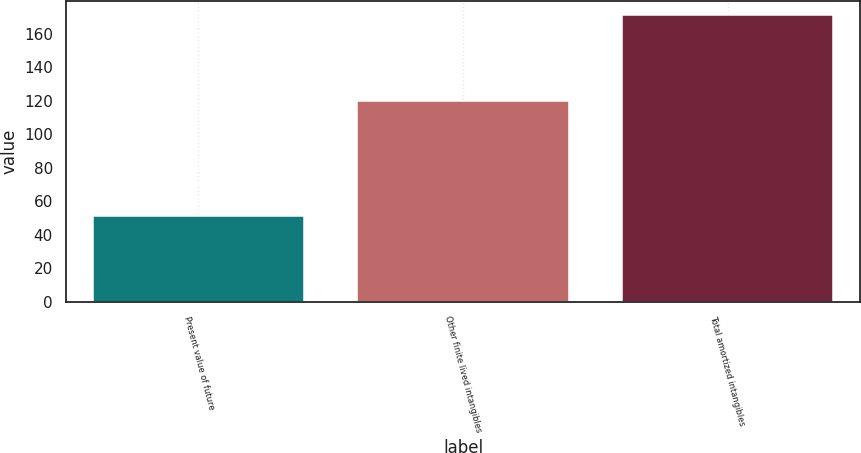Convert chart to OTSL. <chart><loc_0><loc_0><loc_500><loc_500><bar_chart><fcel>Present value of future<fcel>Other finite lived intangibles<fcel>Total amortized intangibles<nl><fcel>51.3<fcel>119.7<fcel>171<nl></chart> 